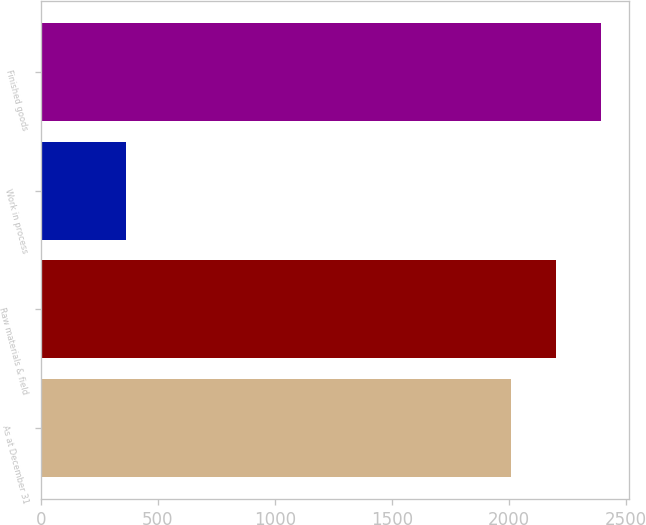<chart> <loc_0><loc_0><loc_500><loc_500><bar_chart><fcel>As at December 31<fcel>Raw materials & field<fcel>Work in process<fcel>Finished goods<nl><fcel>2011<fcel>2201.6<fcel>364<fcel>2392.2<nl></chart> 